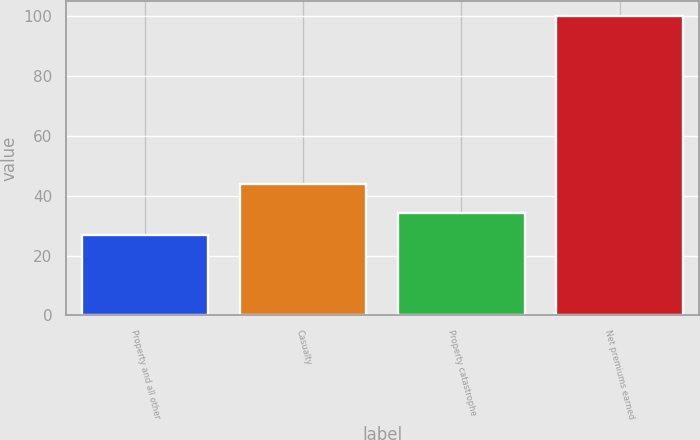Convert chart. <chart><loc_0><loc_0><loc_500><loc_500><bar_chart><fcel>Property and all other<fcel>Casualty<fcel>Property catastrophe<fcel>Net premiums earned<nl><fcel>27<fcel>44<fcel>34.3<fcel>100<nl></chart> 